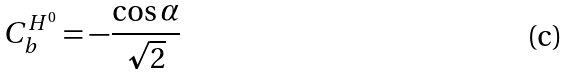<formula> <loc_0><loc_0><loc_500><loc_500>C ^ { H ^ { 0 } } _ { b } = - \frac { \cos \alpha } { \sqrt { 2 } }</formula> 